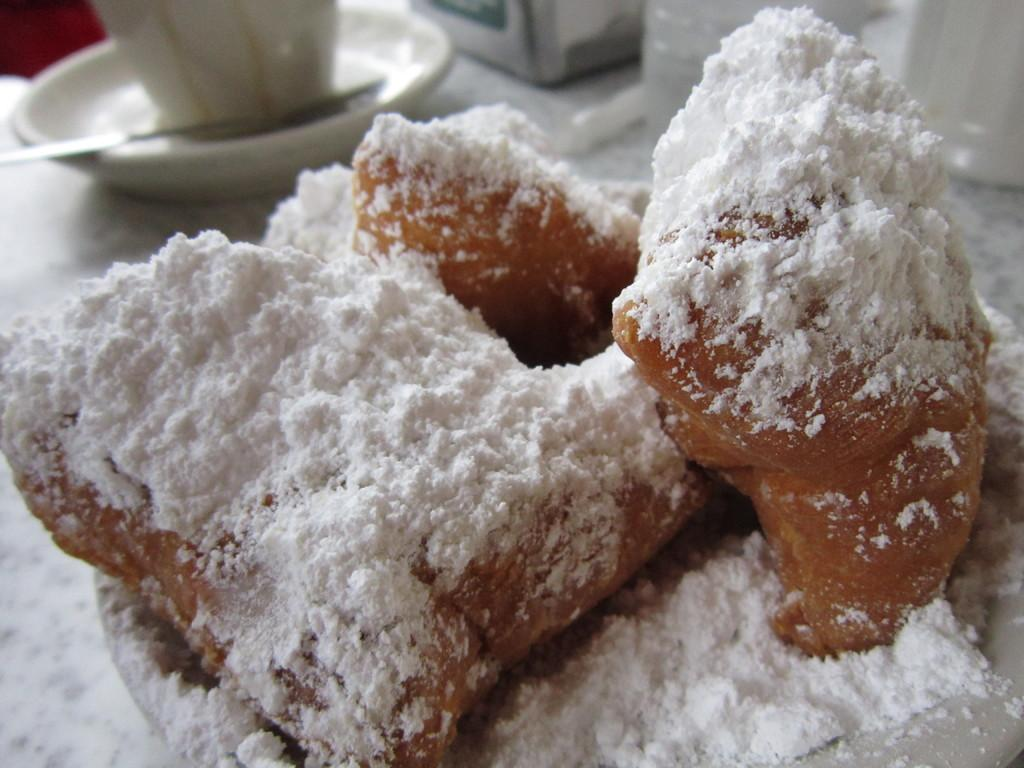What type of food is visible in the image? There is food in the image, but the specific type cannot be determined from the provided facts. What is the cup used for in the image? The purpose of the cup cannot be determined from the provided facts. What other objects are present on the platform in the image? There are other objects on the platform in the image, but their specific nature cannot be determined from the provided facts. How many steps are required for the food to be delivered in the image? There is no indication of a delivery process or steps in the image, so it is not possible to determine the number of steps required. 